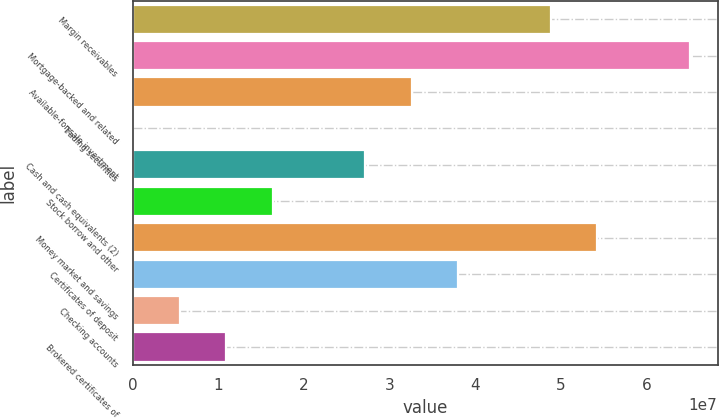Convert chart to OTSL. <chart><loc_0><loc_0><loc_500><loc_500><bar_chart><fcel>Margin receivables<fcel>Mortgage-backed and related<fcel>Available-for-sale investment<fcel>Trading securities<fcel>Cash and cash equivalents (2)<fcel>Stock borrow and other<fcel>Money market and savings<fcel>Certificates of deposit<fcel>Checking accounts<fcel>Brokered certificates of<nl><fcel>4.87923e+07<fcel>6.50194e+07<fcel>3.25651e+07<fcel>110829<fcel>2.71561e+07<fcel>1.6338e+07<fcel>5.42013e+07<fcel>3.79742e+07<fcel>5.51988e+06<fcel>1.09289e+07<nl></chart> 